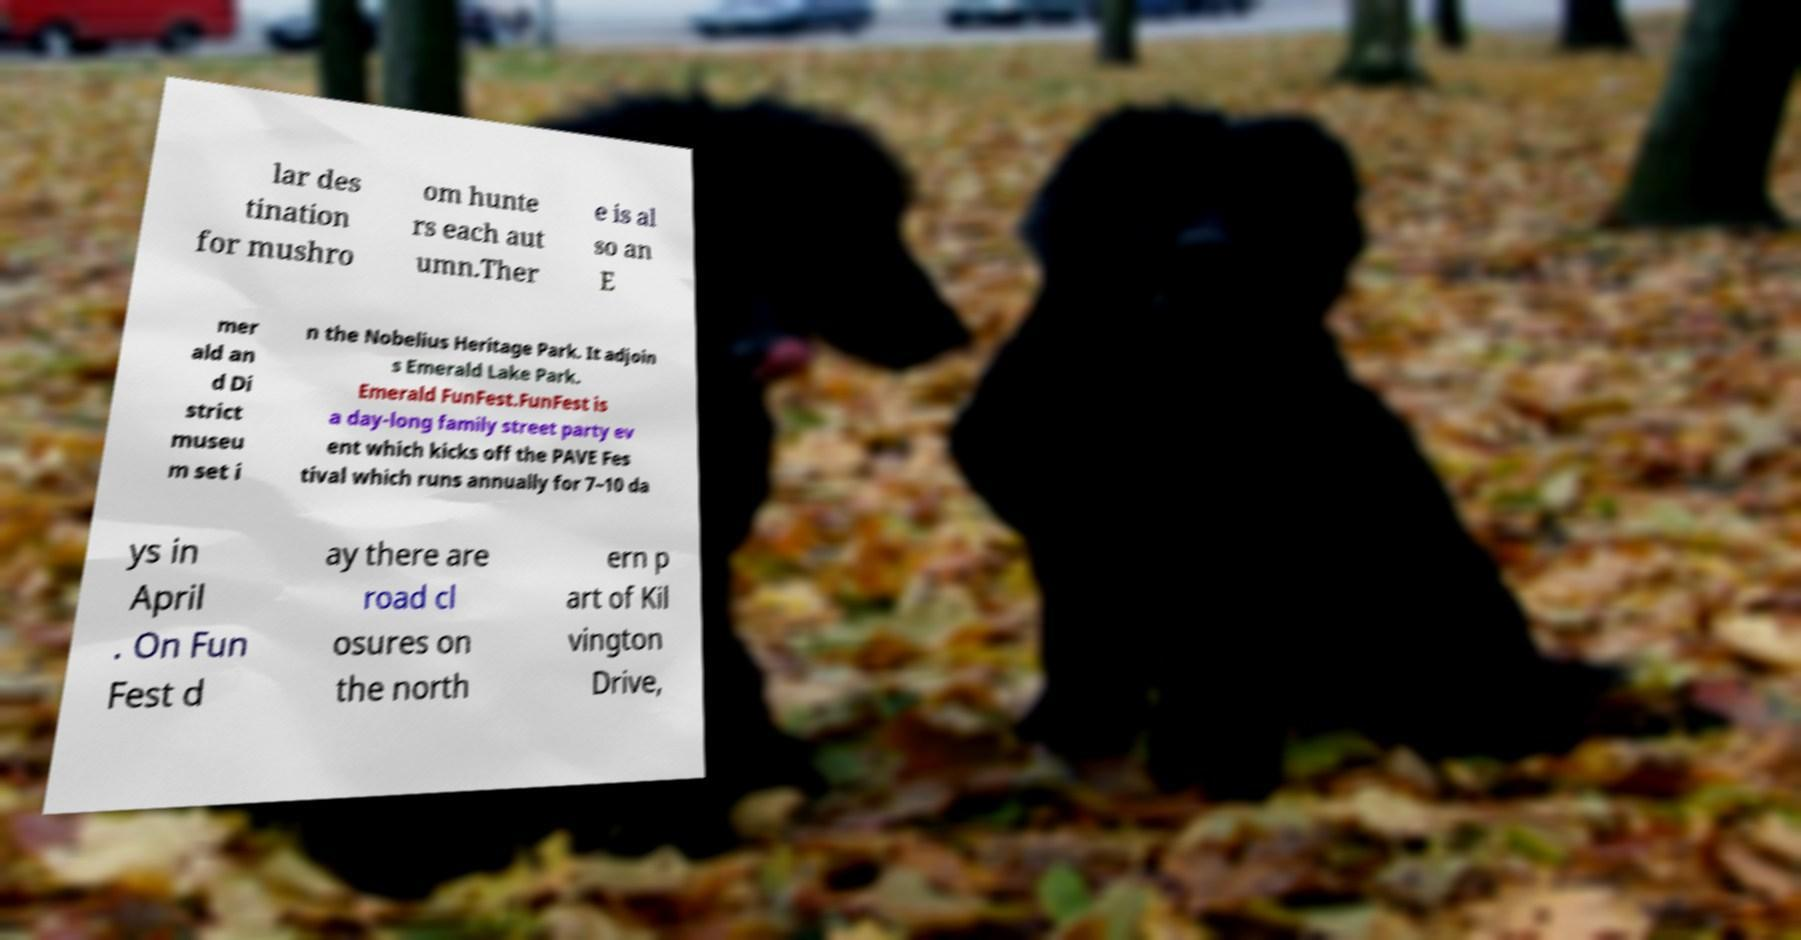Could you extract and type out the text from this image? lar des tination for mushro om hunte rs each aut umn.Ther e is al so an E mer ald an d Di strict museu m set i n the Nobelius Heritage Park. It adjoin s Emerald Lake Park. Emerald FunFest.FunFest is a day-long family street party ev ent which kicks off the PAVE Fes tival which runs annually for 7–10 da ys in April . On Fun Fest d ay there are road cl osures on the north ern p art of Kil vington Drive, 